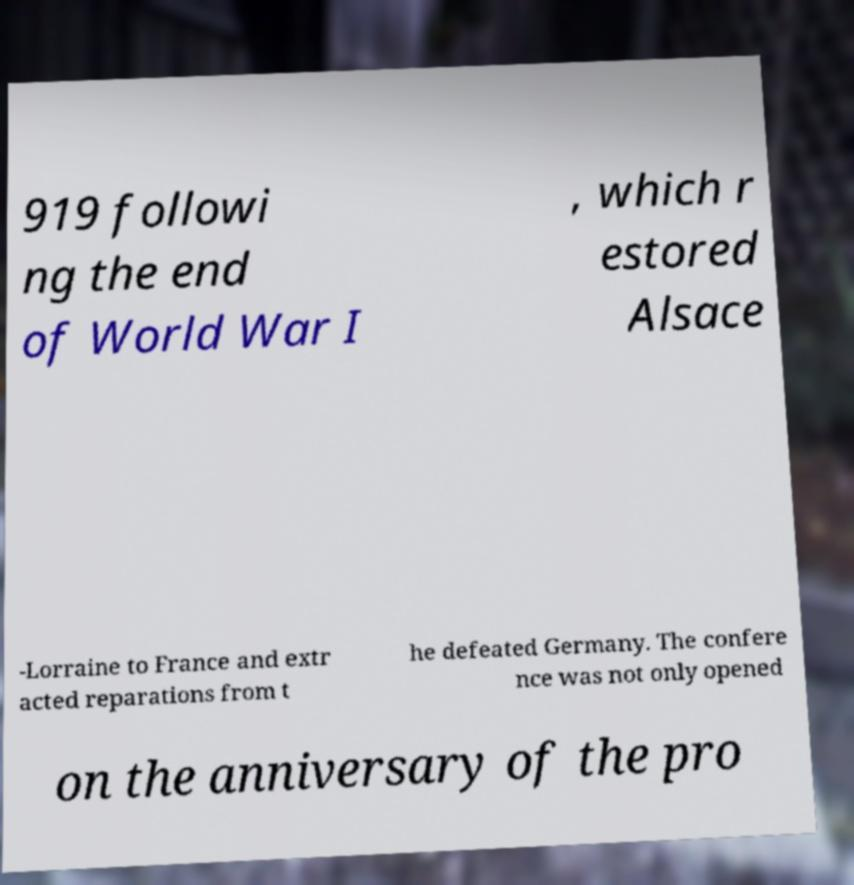Please identify and transcribe the text found in this image. 919 followi ng the end of World War I , which r estored Alsace -Lorraine to France and extr acted reparations from t he defeated Germany. The confere nce was not only opened on the anniversary of the pro 